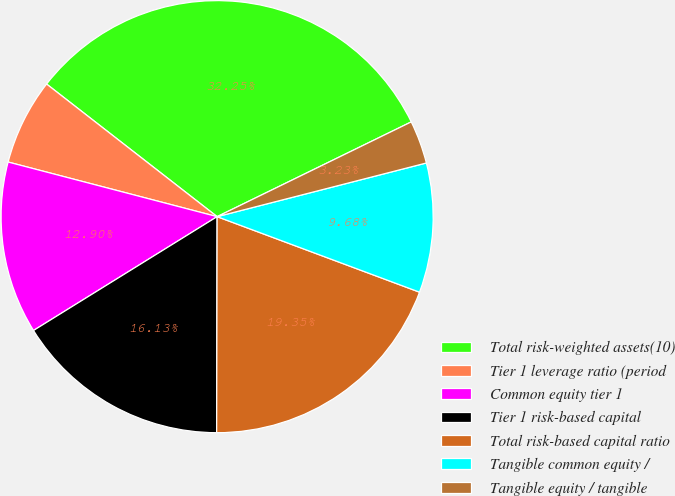Convert chart. <chart><loc_0><loc_0><loc_500><loc_500><pie_chart><fcel>Total risk-weighted assets(10)<fcel>Tier 1 leverage ratio (period<fcel>Common equity tier 1<fcel>Tier 1 risk-based capital<fcel>Total risk-based capital ratio<fcel>Tangible common equity /<fcel>Tangible equity / tangible<nl><fcel>32.25%<fcel>6.45%<fcel>12.9%<fcel>16.13%<fcel>19.35%<fcel>9.68%<fcel>3.23%<nl></chart> 